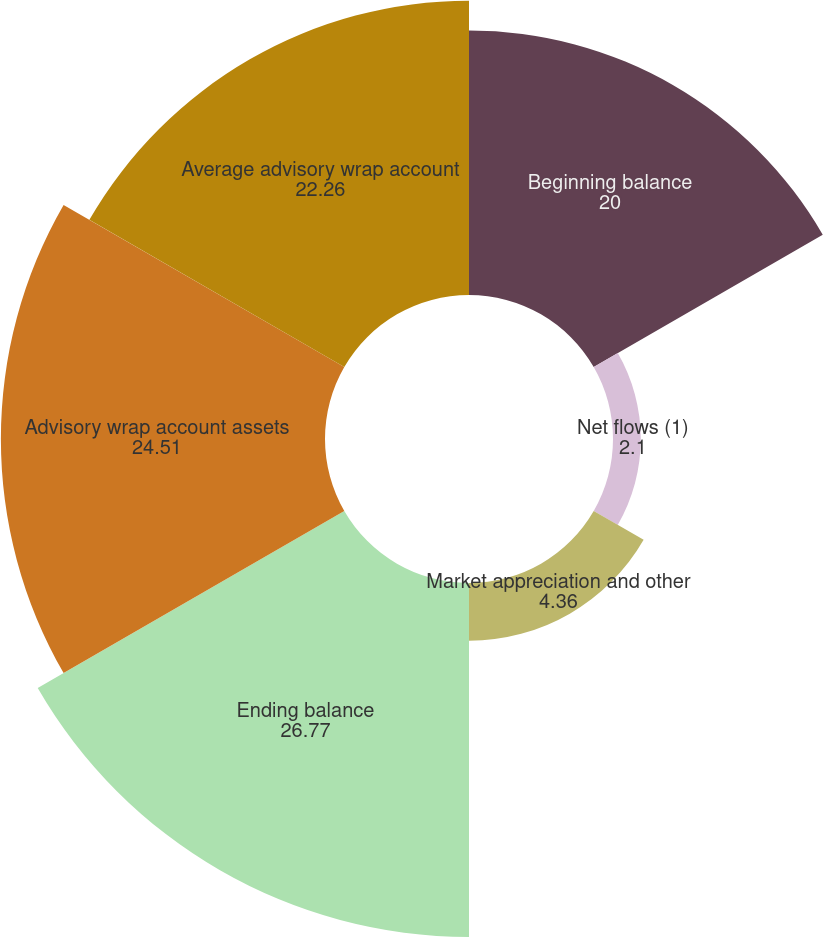Convert chart to OTSL. <chart><loc_0><loc_0><loc_500><loc_500><pie_chart><fcel>Beginning balance<fcel>Net flows (1)<fcel>Market appreciation and other<fcel>Ending balance<fcel>Advisory wrap account assets<fcel>Average advisory wrap account<nl><fcel>20.0%<fcel>2.1%<fcel>4.36%<fcel>26.77%<fcel>24.51%<fcel>22.26%<nl></chart> 